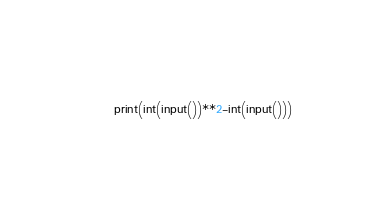<code> <loc_0><loc_0><loc_500><loc_500><_Python_>print(int(input())**2-int(input()))</code> 